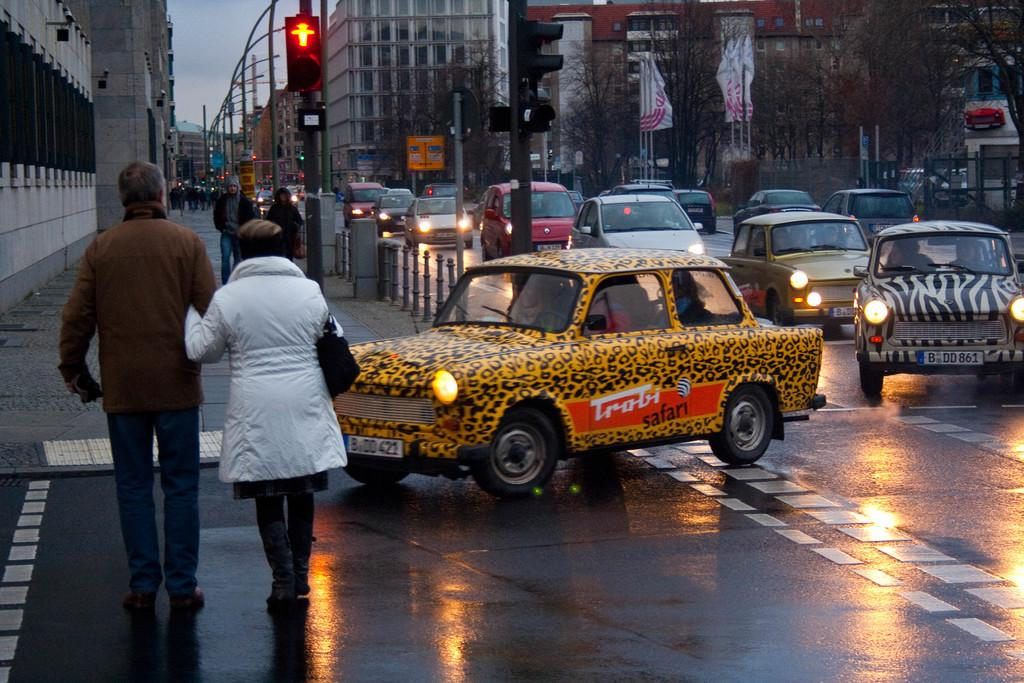<image>
Summarize the visual content of the image. A car painted like an animal says Trobi Safari on the side. 